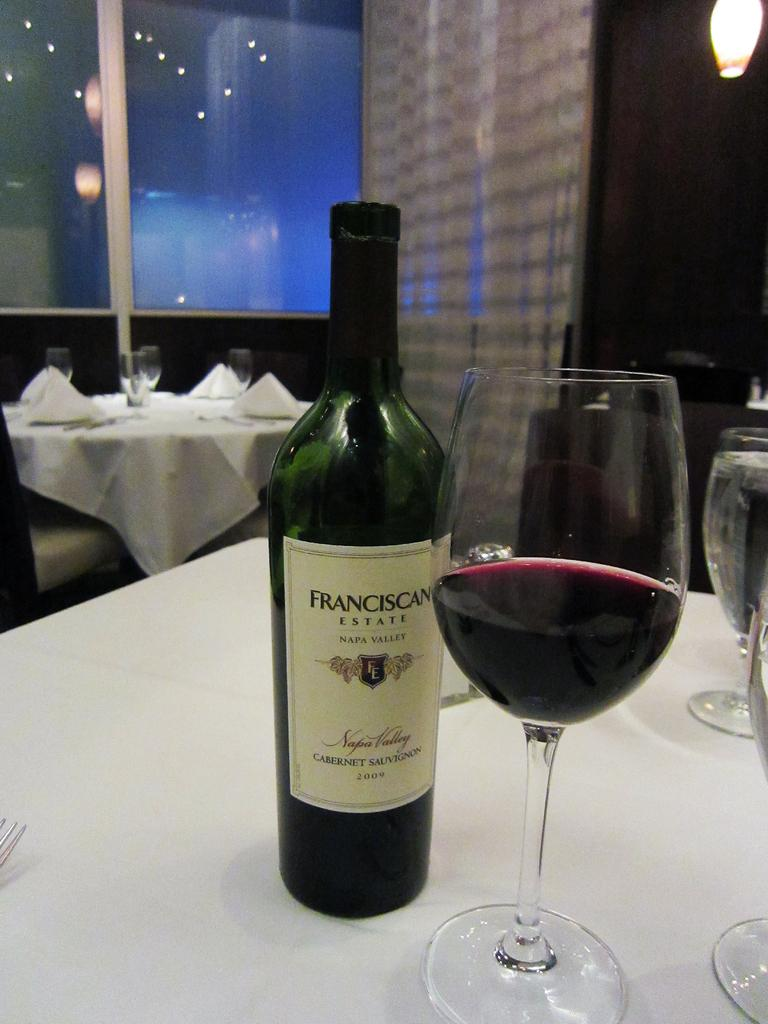<image>
Render a clear and concise summary of the photo. A bottle of Franciscan Cabernet Sauvignon is on a table next to a wine glass. 